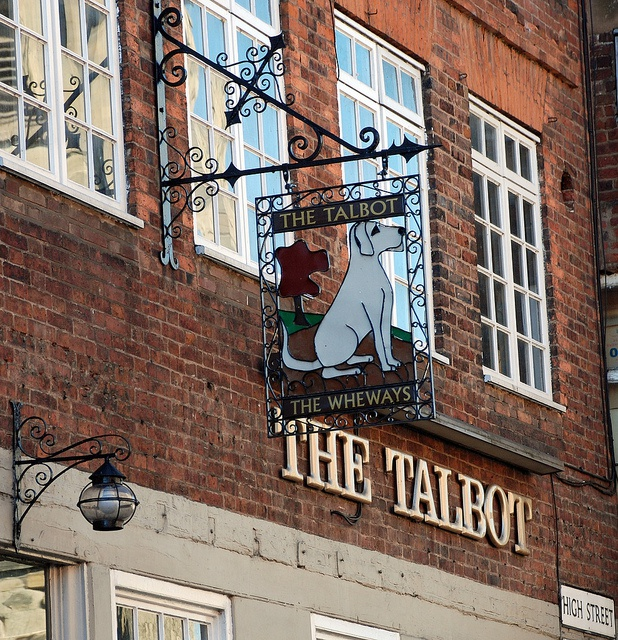Describe the objects in this image and their specific colors. I can see various objects in this image with different colors. 